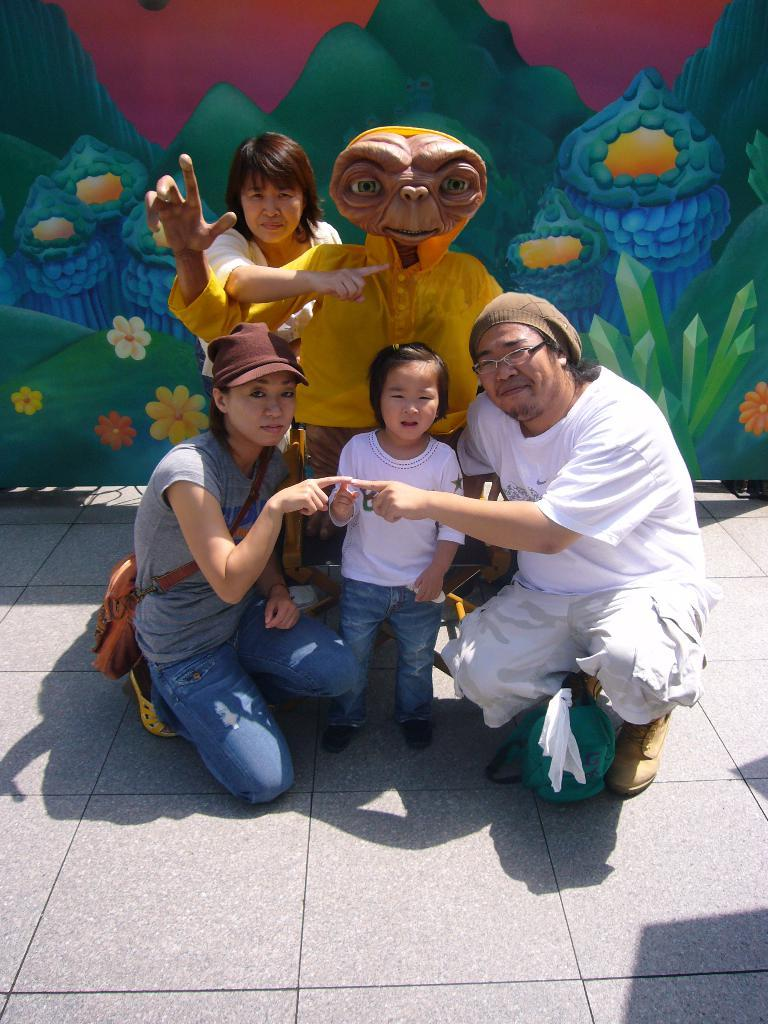What is the main subject in the image? There is a statue in the image. How many people are present in the image? There are four people on the ground in the image. What can be seen on the wall in the background of the image? There is a painting on the wall in the background of the image. What type of whip is being used by the statue in the image? There is no whip present in the image; the statue is stationary. What is the title of the painting on the wall in the image? The provided facts do not mention the title of the painting, so we cannot determine it from the image. 